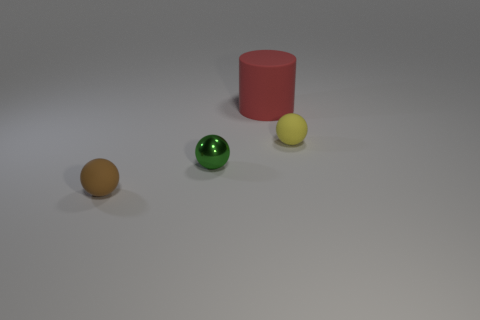Add 3 green metal balls. How many objects exist? 7 Subtract all balls. How many objects are left? 1 Subtract all large blue metal spheres. Subtract all green balls. How many objects are left? 3 Add 1 tiny yellow objects. How many tiny yellow objects are left? 2 Add 2 gray shiny things. How many gray shiny things exist? 2 Subtract 0 green cubes. How many objects are left? 4 